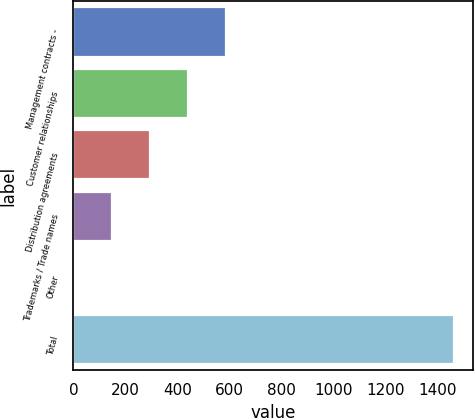Convert chart. <chart><loc_0><loc_0><loc_500><loc_500><bar_chart><fcel>Management contracts -<fcel>Customer relationships<fcel>Distribution agreements<fcel>Trademarks / Trade names<fcel>Other<fcel>Total<nl><fcel>585.48<fcel>439.31<fcel>293.14<fcel>146.97<fcel>0.8<fcel>1462.5<nl></chart> 